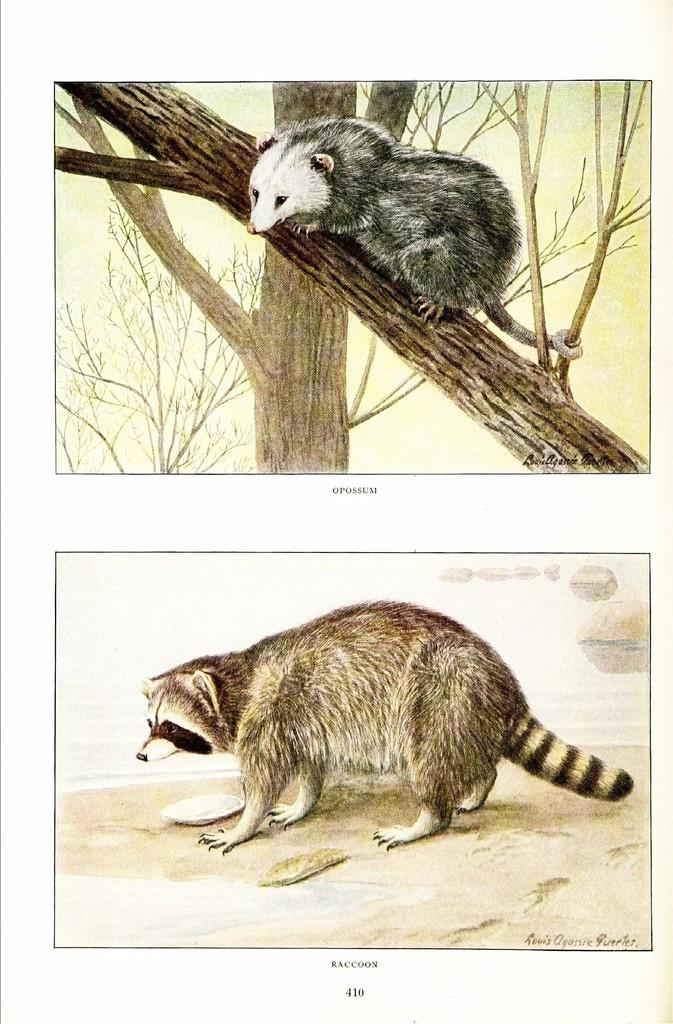What animals are depicted in the sketches in the image? There is a sketch of a rat on a tree and a sketch of a fox below it in the image. Can you describe the positioning of the sketches in relation to each other? The sketch of the rat is on a tree, and the sketch of the fox is below it. What is present in front of the fox sketch? There is an object in front of the fox sketch. What type of cable is being used to hold the question in the image? There is no cable or question present in the image; it only contains sketches of a rat and a fox. Is there a stick being used to draw the sketches in the image? The facts provided do not mention any sticks or drawing tools used to create the sketches in the image. 